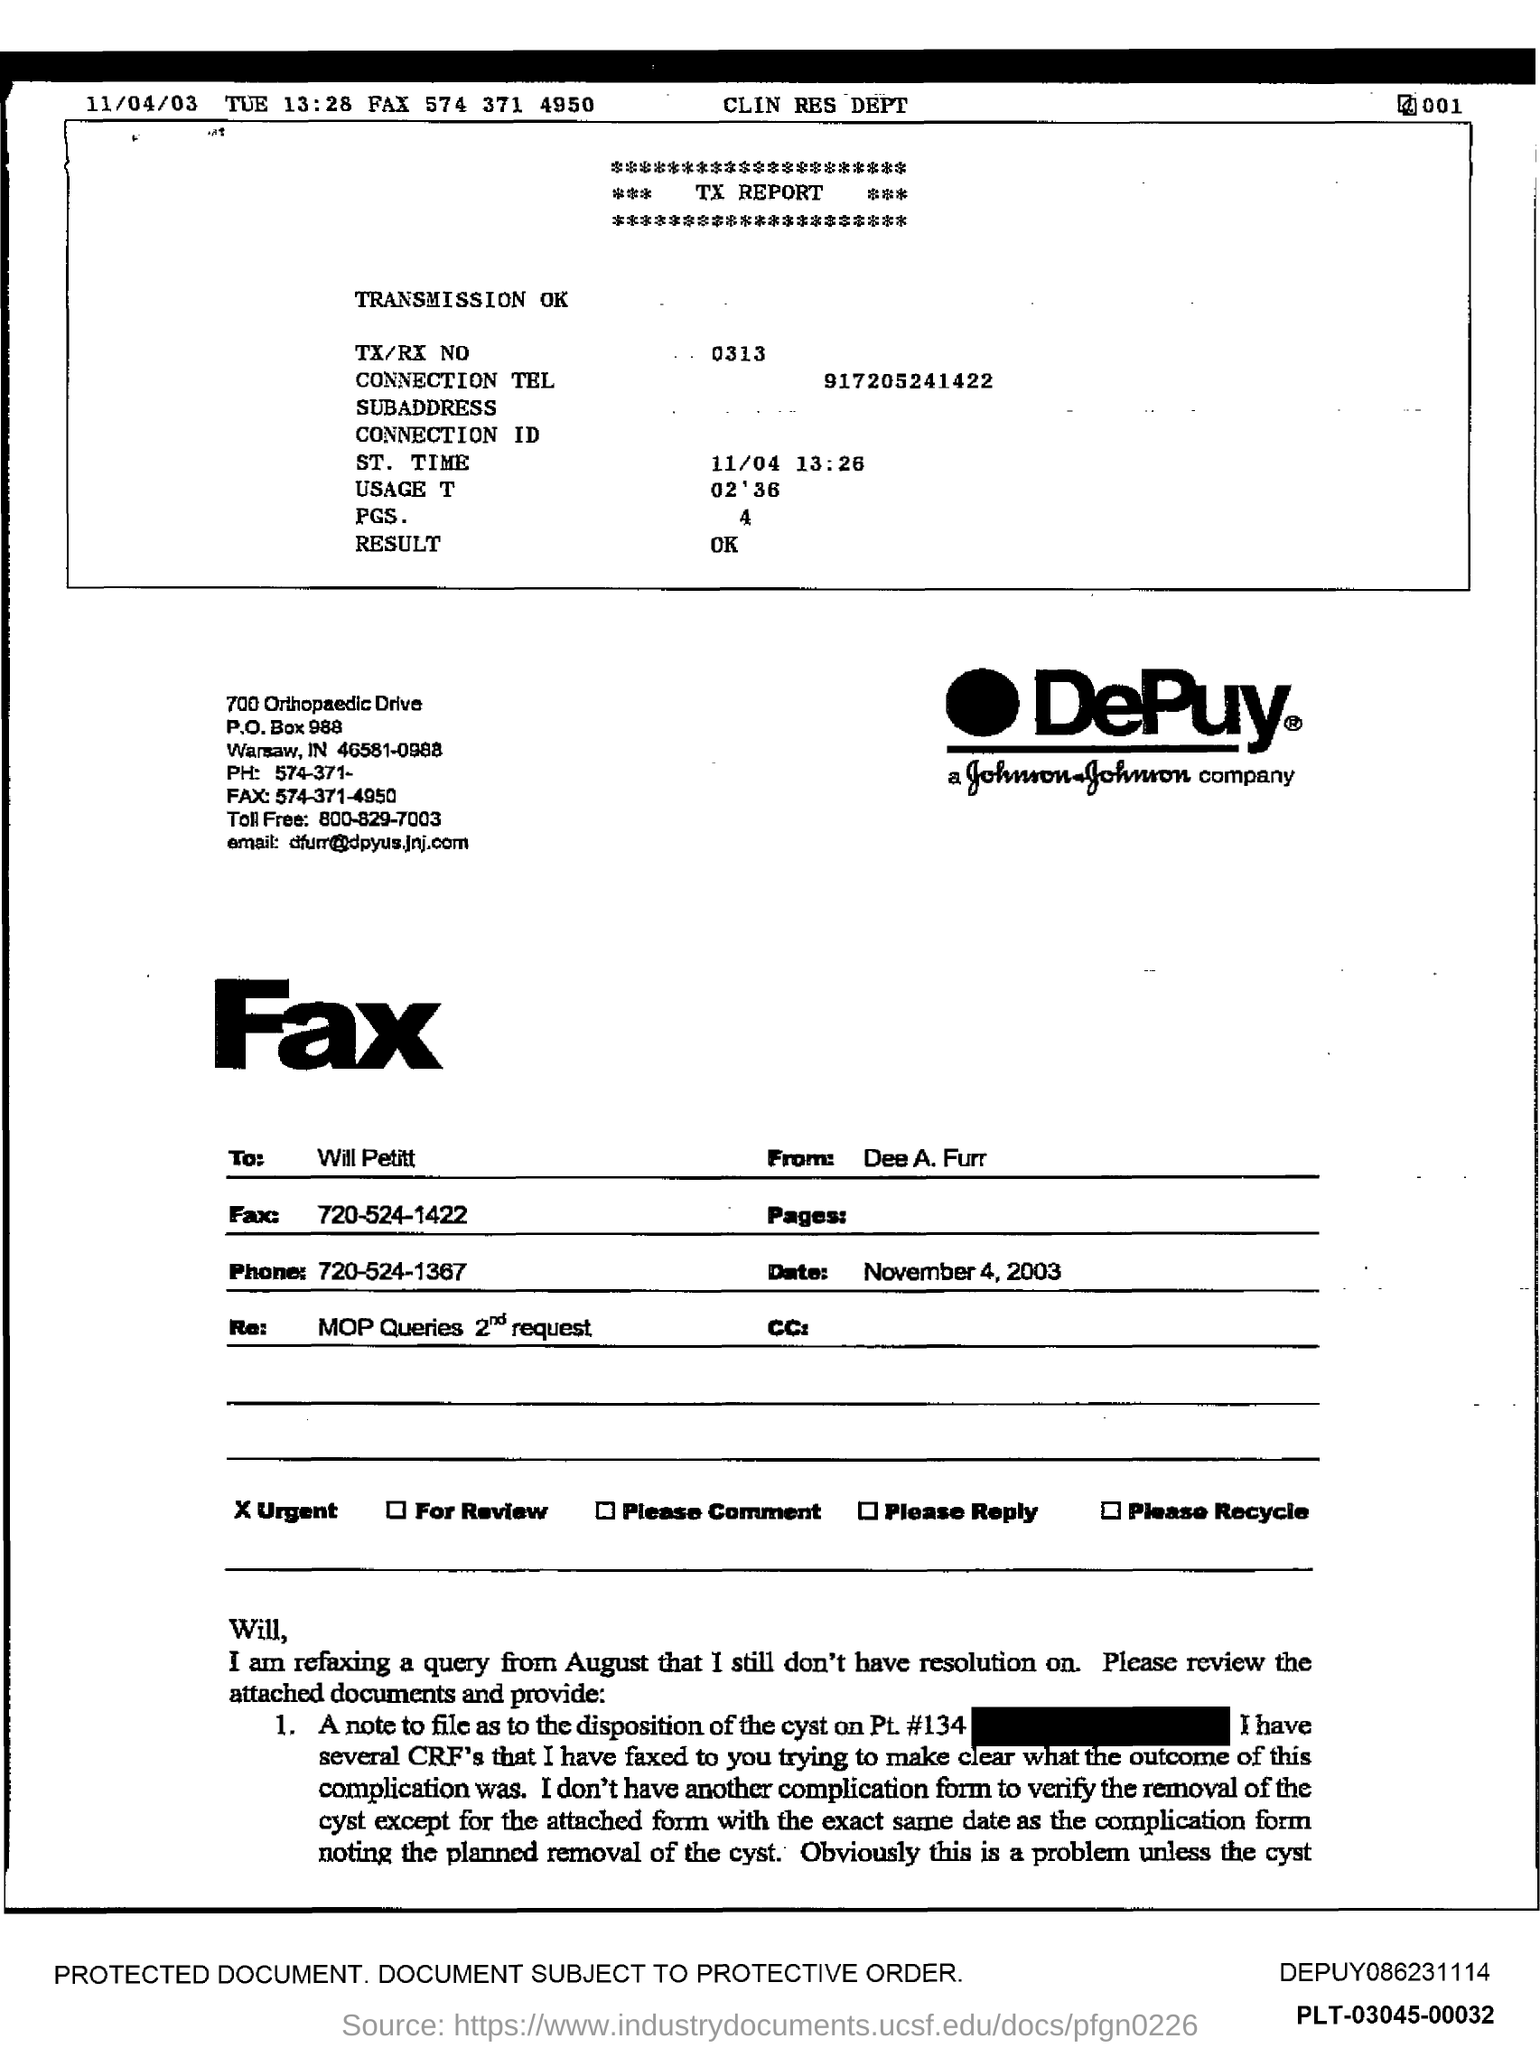What is the date given on the left? The date given on the left side of the fax is November 4, 2003, as indicated by the timestamp '11/04/03' at the top of the document. 